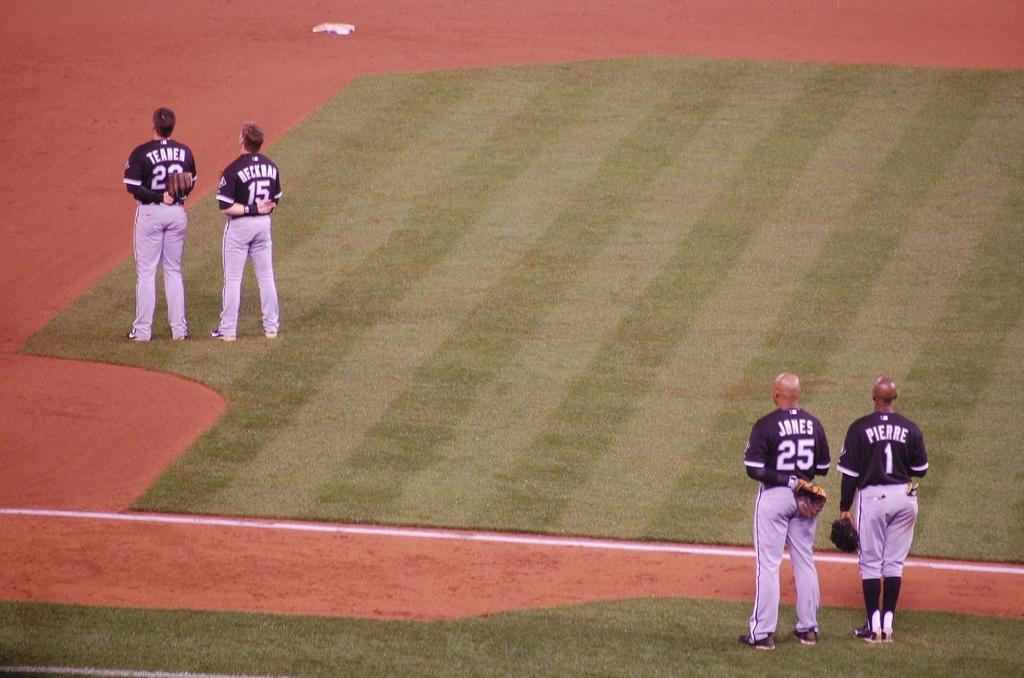<image>
Describe the image concisely. Teahen, Beckham, Jones, and Pierre are the baseball players standing for the anthem at the field. 